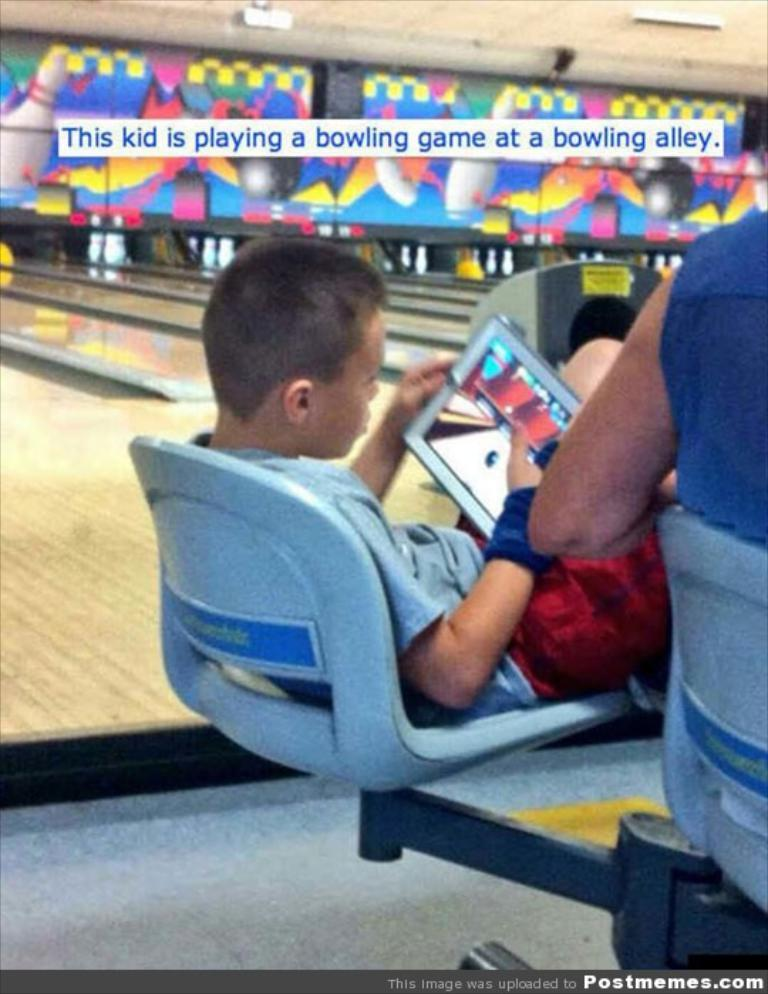<image>
Give a short and clear explanation of the subsequent image. A kid playing a bowling game on an iPad while at a bowling alley. 